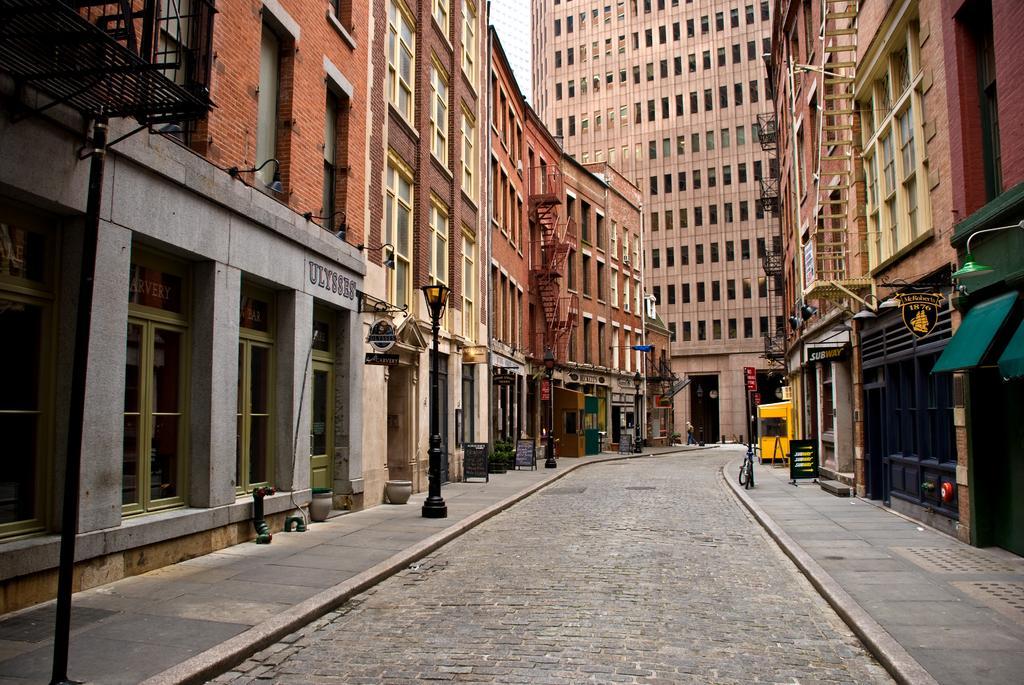Please provide a concise description of this image. In this image, there are a few buildings, poles. We can see the ground with some objects. We can also see some black colored objects on the top left corner. 